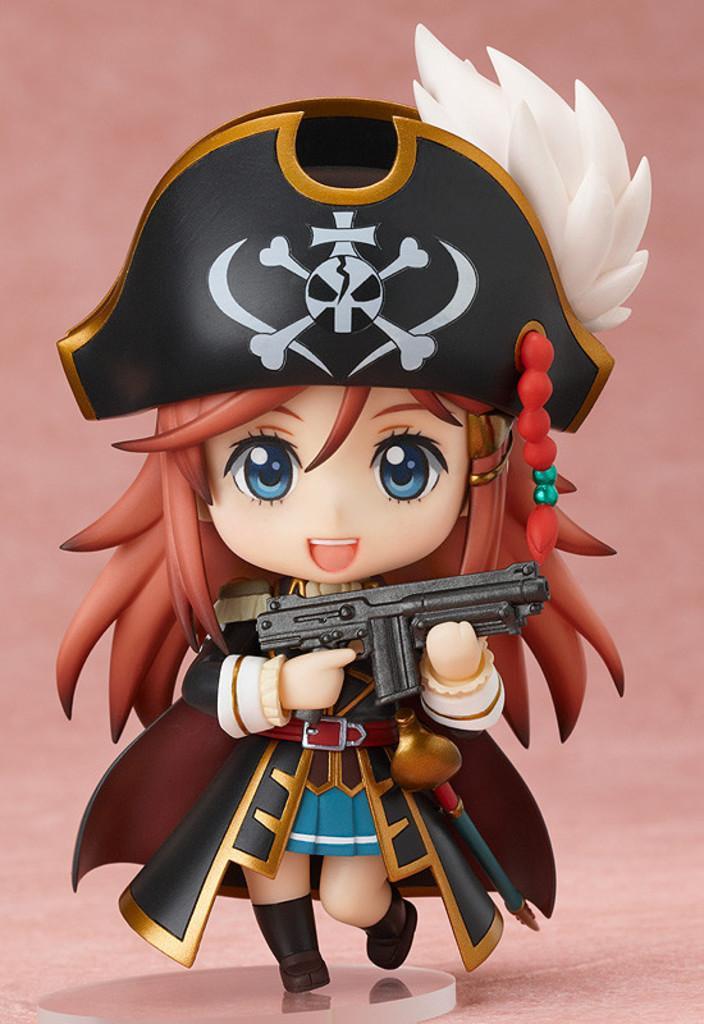How would you summarize this image in a sentence or two? This is an animated image. In this picture, we see a cartoon toy which is holding a gun. In the background, it is pink in color. 